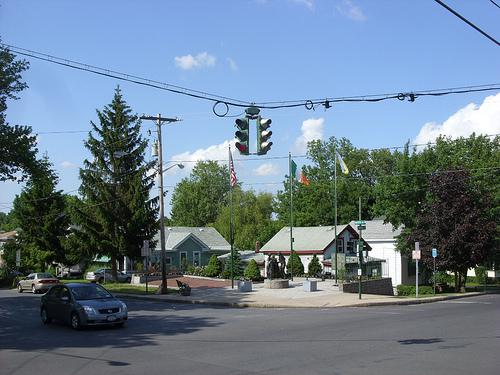Question: how many cars are shown at the intersection?
Choices:
A. 2.
B. 3.
C. 1.
D. 4.
Answer with the letter. Answer: C Question: what vehicle is on the road?
Choices:
A. Bus.
B. Truck.
C. Airplane.
D. Car.
Answer with the letter. Answer: D Question: where is this shot?
Choices:
A. Highway.
B. Country road.
C. Gas station.
D. Intersection.
Answer with the letter. Answer: D Question: when was this taken?
Choices:
A. Midnight.
B. Sunrise.
C. Afternoon.
D. Daytime.
Answer with the letter. Answer: D 